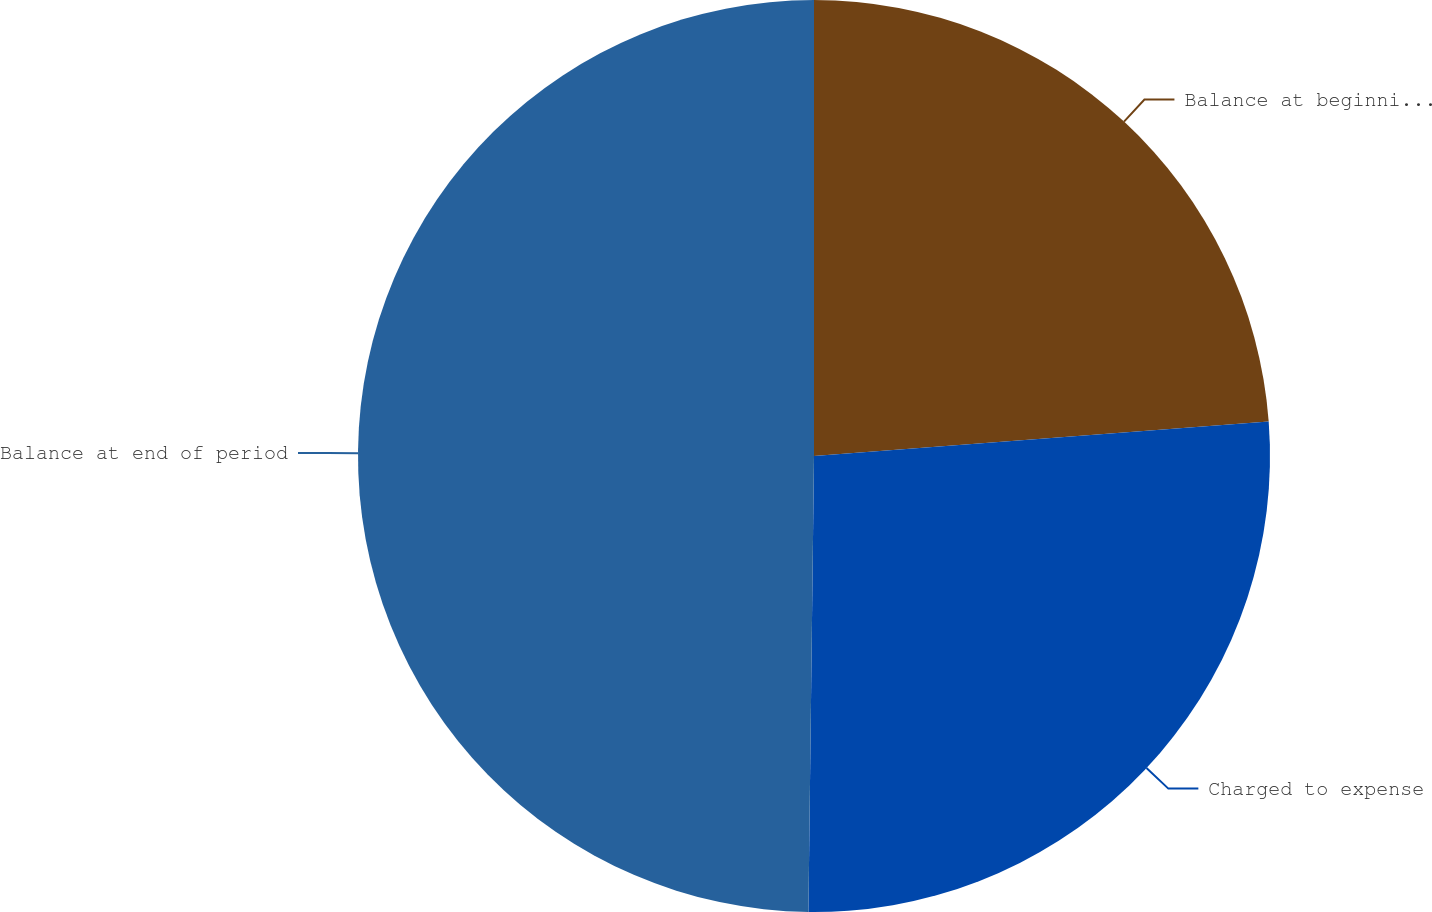Convert chart to OTSL. <chart><loc_0><loc_0><loc_500><loc_500><pie_chart><fcel>Balance at beginning of period<fcel>Charged to expense<fcel>Balance at end of period<nl><fcel>23.8%<fcel>26.4%<fcel>49.81%<nl></chart> 